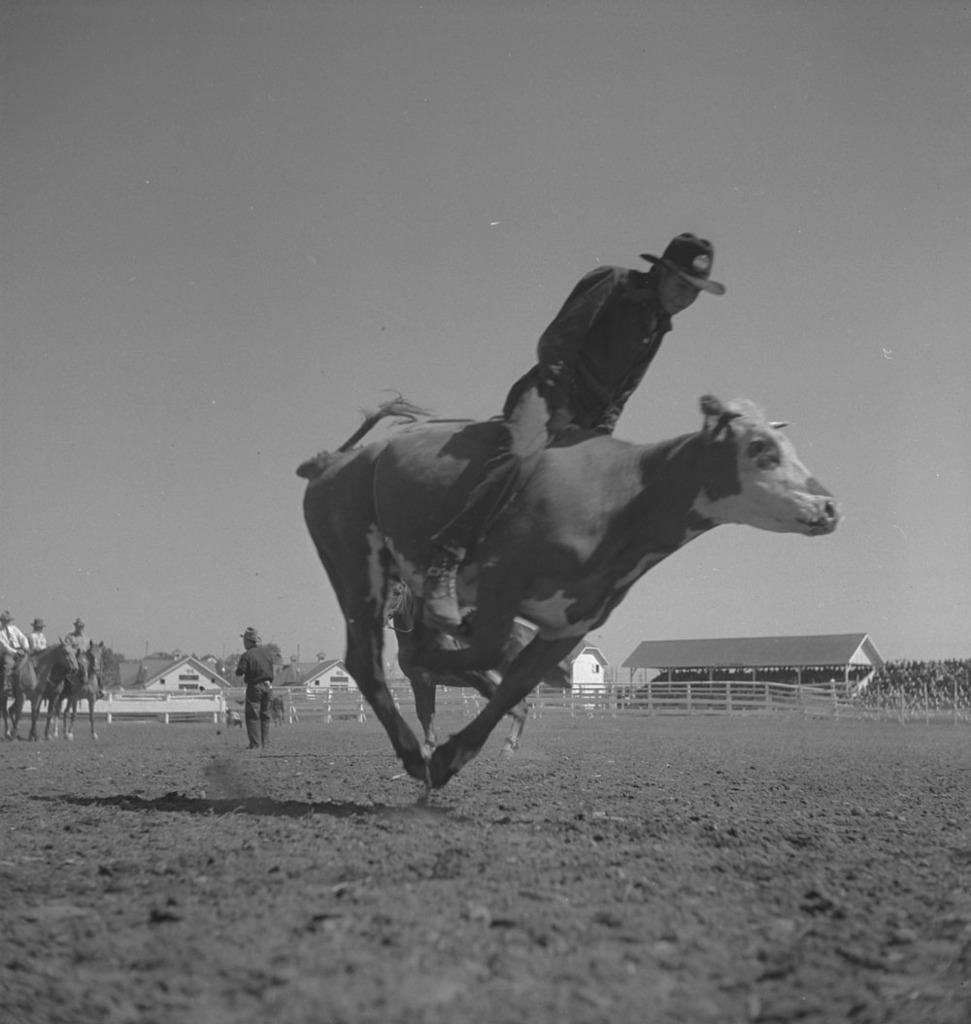Could you give a brief overview of what you see in this image? in this picture there is a boy who is riding on the horse, there is a muddy floor in the image, there is a ware house at the right side of the image, it seems to be a training center. 